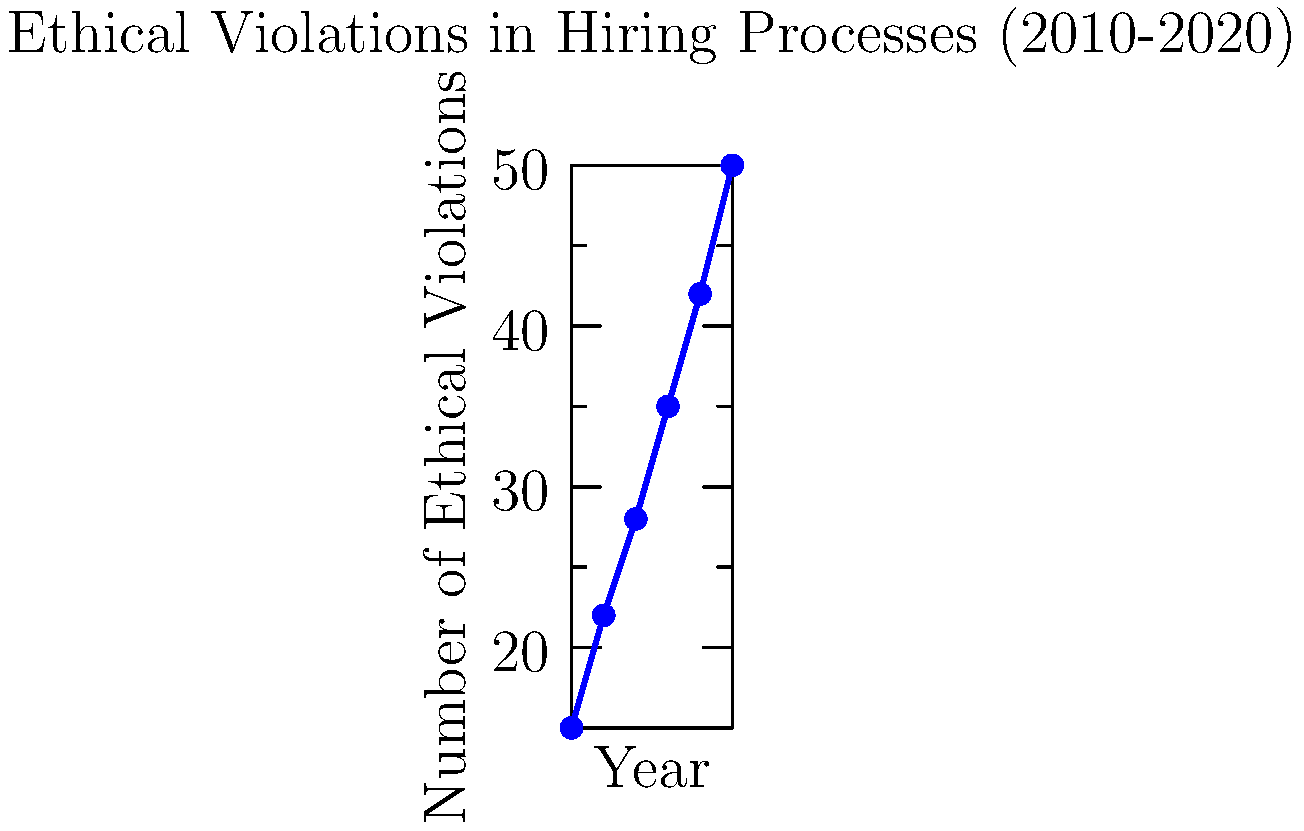Based on the line graph depicting ethical violations in hiring processes from 2010 to 2020, what is the average rate of increase in violations per year? To calculate the average rate of increase in ethical violations per year:

1. Calculate total increase: 50 (2020) - 15 (2010) = 35 violations
2. Determine time span: 2020 - 2010 = 10 years
3. Calculate average rate: 35 violations / 10 years = 3.5 violations per year

Let's verify using the slope formula:
$$ \text{Slope} = \frac{y_2 - y_1}{x_2 - x_1} = \frac{50 - 15}{2020 - 2010} = \frac{35}{10} = 3.5 $$

This confirms that the average rate of increase is 3.5 violations per year.
Answer: 3.5 violations/year 